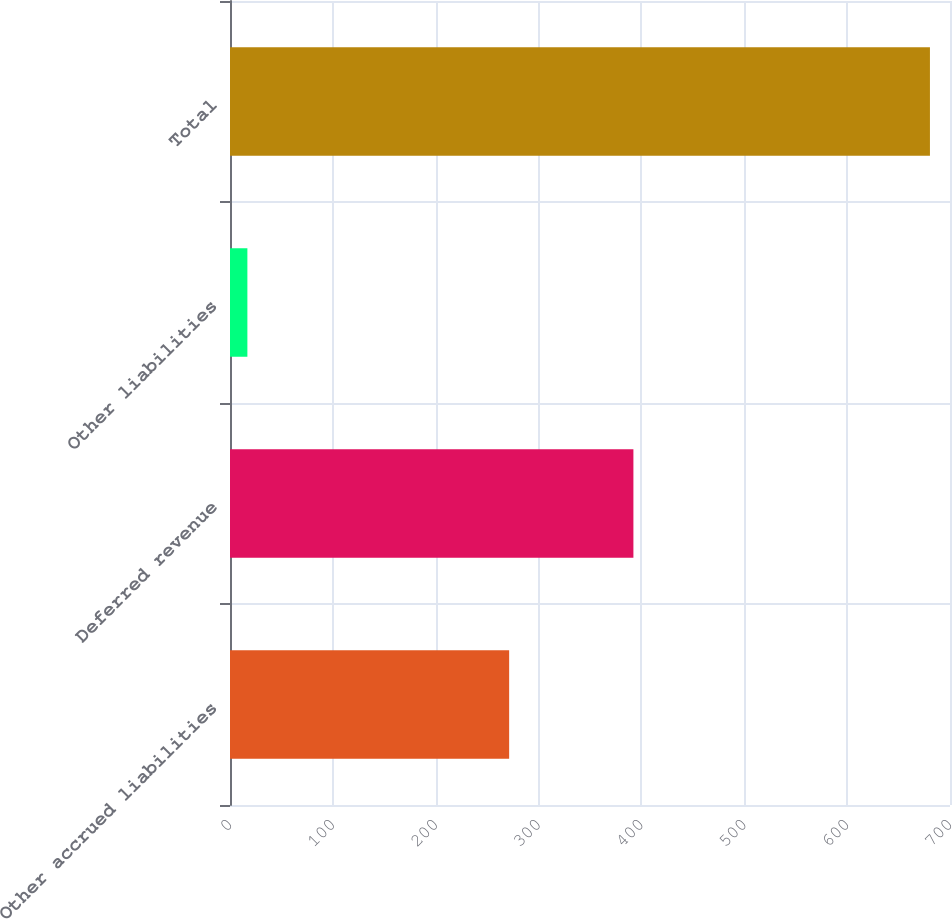Convert chart to OTSL. <chart><loc_0><loc_0><loc_500><loc_500><bar_chart><fcel>Other accrued liabilities<fcel>Deferred revenue<fcel>Other liabilities<fcel>Total<nl><fcel>271.4<fcel>392.2<fcel>16.9<fcel>680.5<nl></chart> 